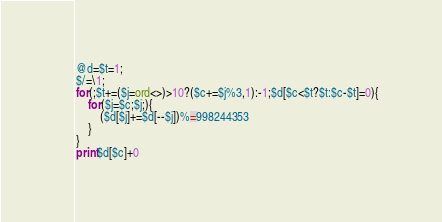<code> <loc_0><loc_0><loc_500><loc_500><_Perl_>@d=$t=1;
$/=\1;
for(;$t+=($j=ord<>)>10?($c+=$j%3,1):-1;$d[$c<$t?$t:$c-$t]=0){
	for($j=$c;$j;){
		($d[$j]+=$d[--$j])%=998244353
	}
}
print$d[$c]+0</code> 